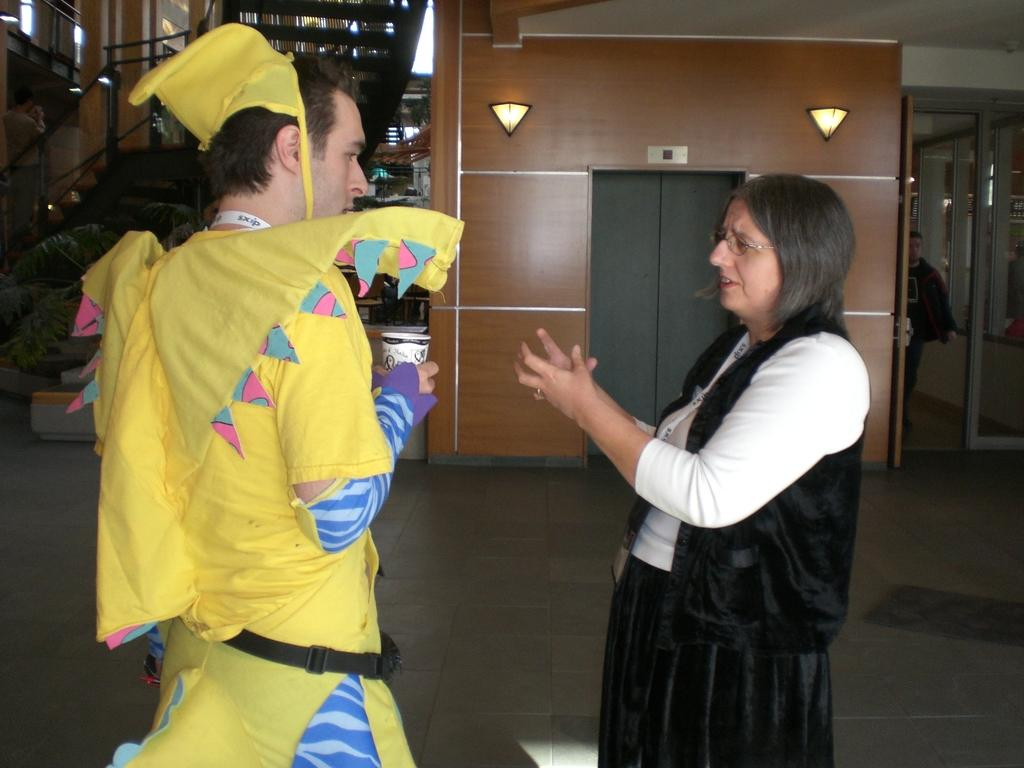What is the man in the image wearing? The man is wearing a costume in the image. Where is the man located in the image? The man is on the left side of the image. What can be seen on the right side of the image? There is a door on the right side of the image. What is happening in the middle of the image? A woman is talking in the middle of the image. What is visible on the wall in the background of the image? There are lights on the wall in the background of the image. How many cows are present in the image? There are no cows present in the image. What type of skate is the man using to move around in the image? The man is not using a skate to move around in the image; he is standing still on the left side. 